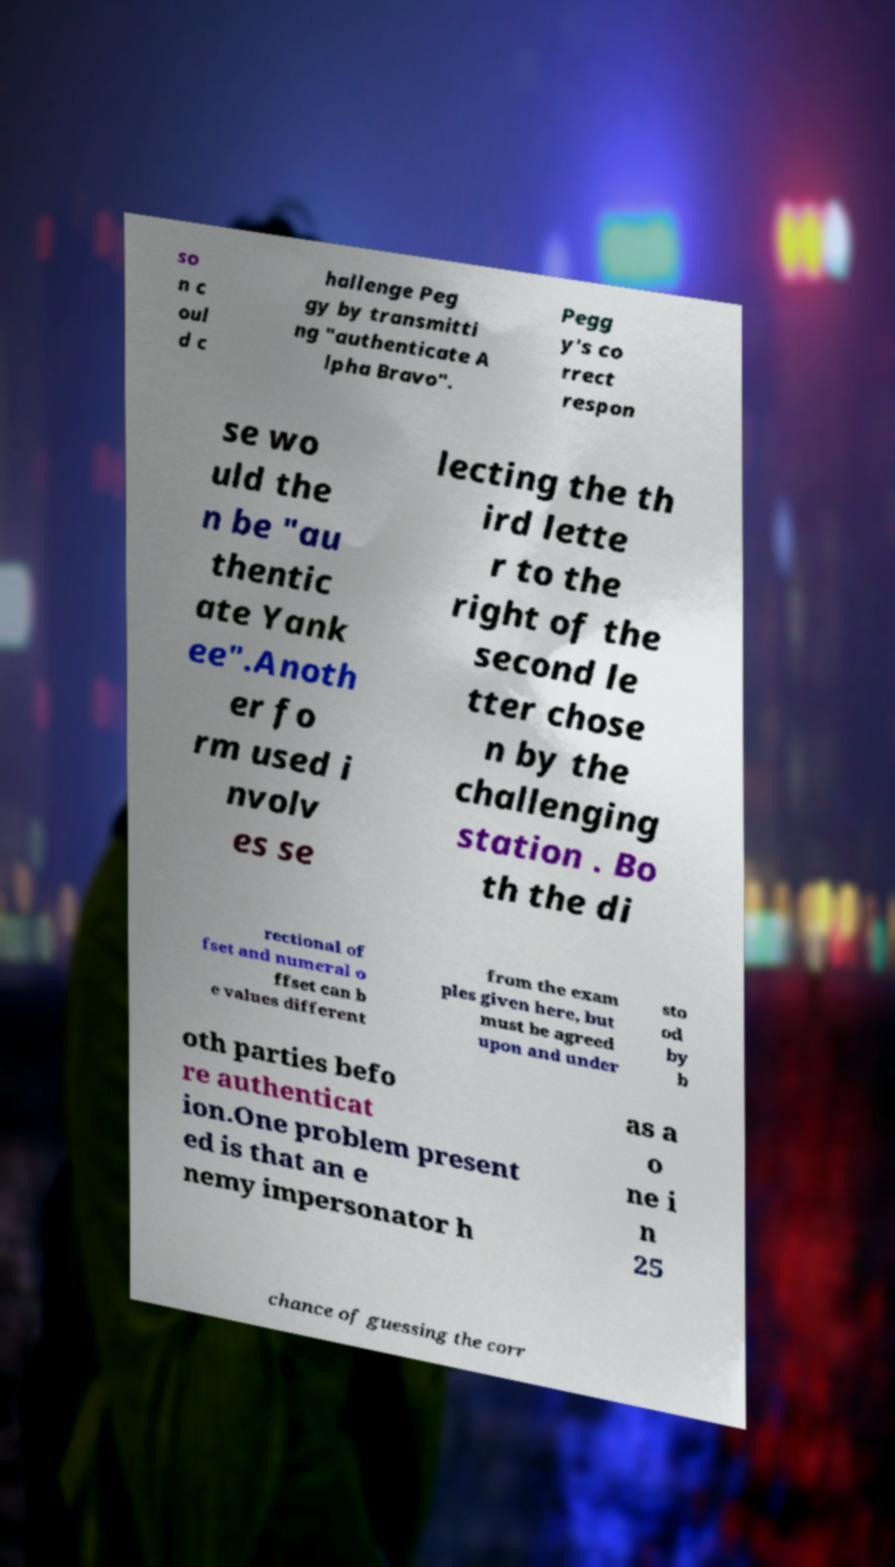Please identify and transcribe the text found in this image. so n c oul d c hallenge Peg gy by transmitti ng "authenticate A lpha Bravo". Pegg y's co rrect respon se wo uld the n be "au thentic ate Yank ee".Anoth er fo rm used i nvolv es se lecting the th ird lette r to the right of the second le tter chose n by the challenging station . Bo th the di rectional of fset and numeral o ffset can b e values different from the exam ples given here, but must be agreed upon and under sto od by b oth parties befo re authenticat ion.One problem present ed is that an e nemy impersonator h as a o ne i n 25 chance of guessing the corr 